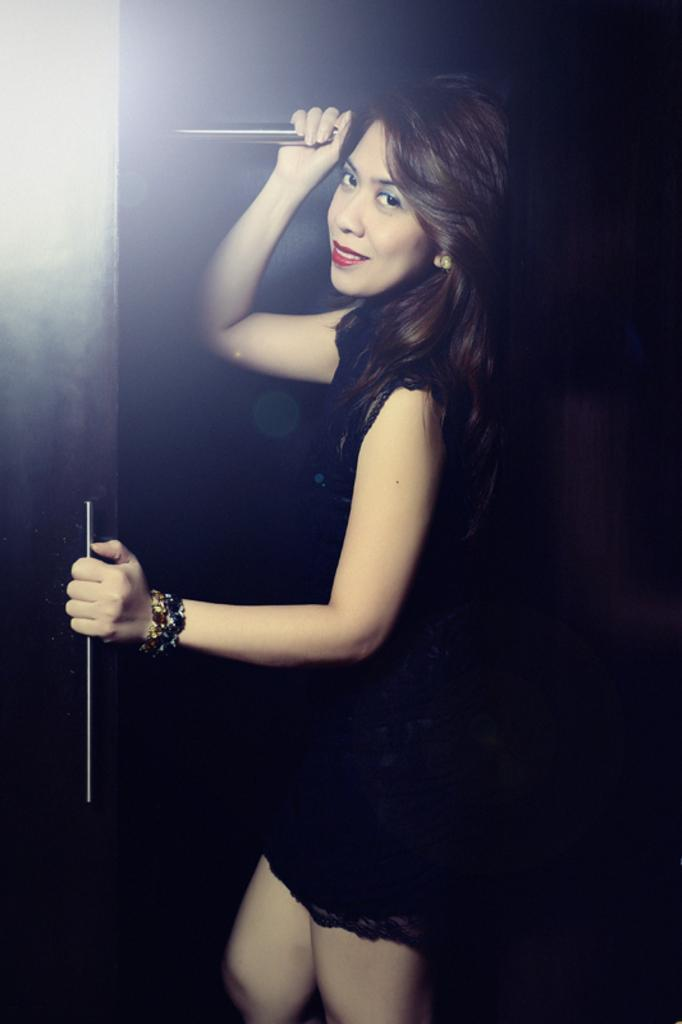Who is the main subject in the image? There is a woman in the image. What is the woman wearing? The woman is wearing a black dress. What is the woman holding in the image? The woman is holding a door. What type of berry can be seen on the woman's dress in the image? There are no berries visible on the woman's dress in the image. 